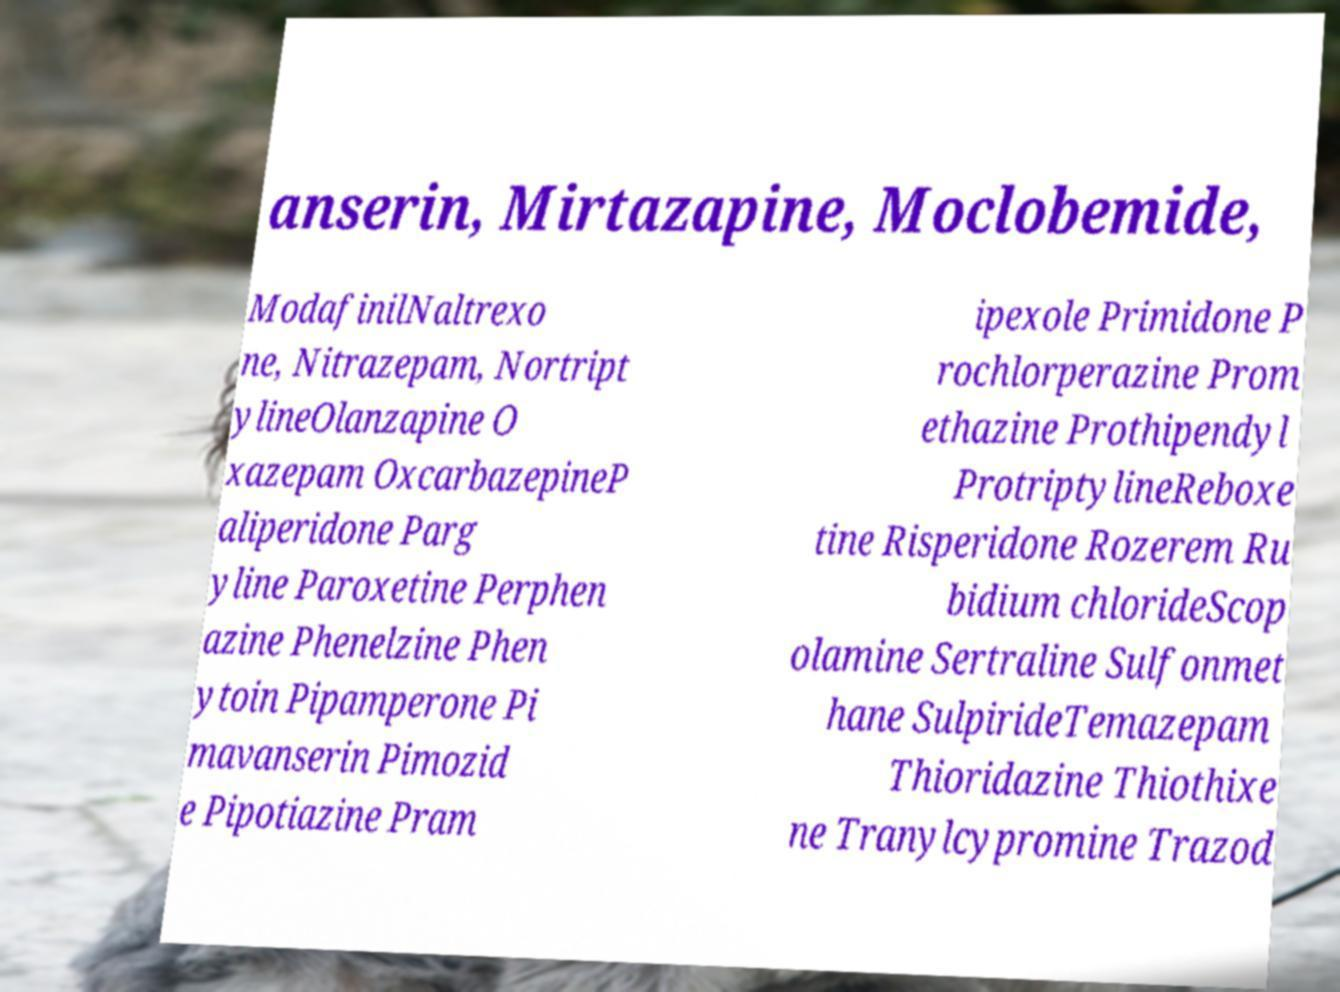There's text embedded in this image that I need extracted. Can you transcribe it verbatim? anserin, Mirtazapine, Moclobemide, ModafinilNaltrexo ne, Nitrazepam, Nortript ylineOlanzapine O xazepam OxcarbazepineP aliperidone Parg yline Paroxetine Perphen azine Phenelzine Phen ytoin Pipamperone Pi mavanserin Pimozid e Pipotiazine Pram ipexole Primidone P rochlorperazine Prom ethazine Prothipendyl ProtriptylineReboxe tine Risperidone Rozerem Ru bidium chlorideScop olamine Sertraline Sulfonmet hane SulpirideTemazepam Thioridazine Thiothixe ne Tranylcypromine Trazod 